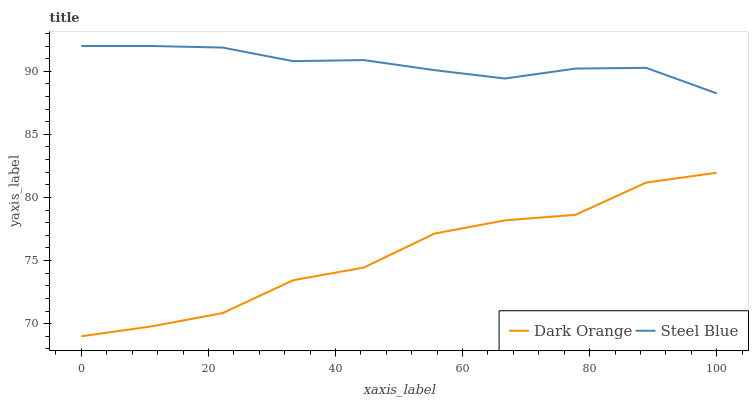Does Dark Orange have the minimum area under the curve?
Answer yes or no. Yes. Does Steel Blue have the maximum area under the curve?
Answer yes or no. Yes. Does Steel Blue have the minimum area under the curve?
Answer yes or no. No. Is Steel Blue the smoothest?
Answer yes or no. Yes. Is Dark Orange the roughest?
Answer yes or no. Yes. Is Steel Blue the roughest?
Answer yes or no. No. Does Dark Orange have the lowest value?
Answer yes or no. Yes. Does Steel Blue have the lowest value?
Answer yes or no. No. Does Steel Blue have the highest value?
Answer yes or no. Yes. Is Dark Orange less than Steel Blue?
Answer yes or no. Yes. Is Steel Blue greater than Dark Orange?
Answer yes or no. Yes. Does Dark Orange intersect Steel Blue?
Answer yes or no. No. 